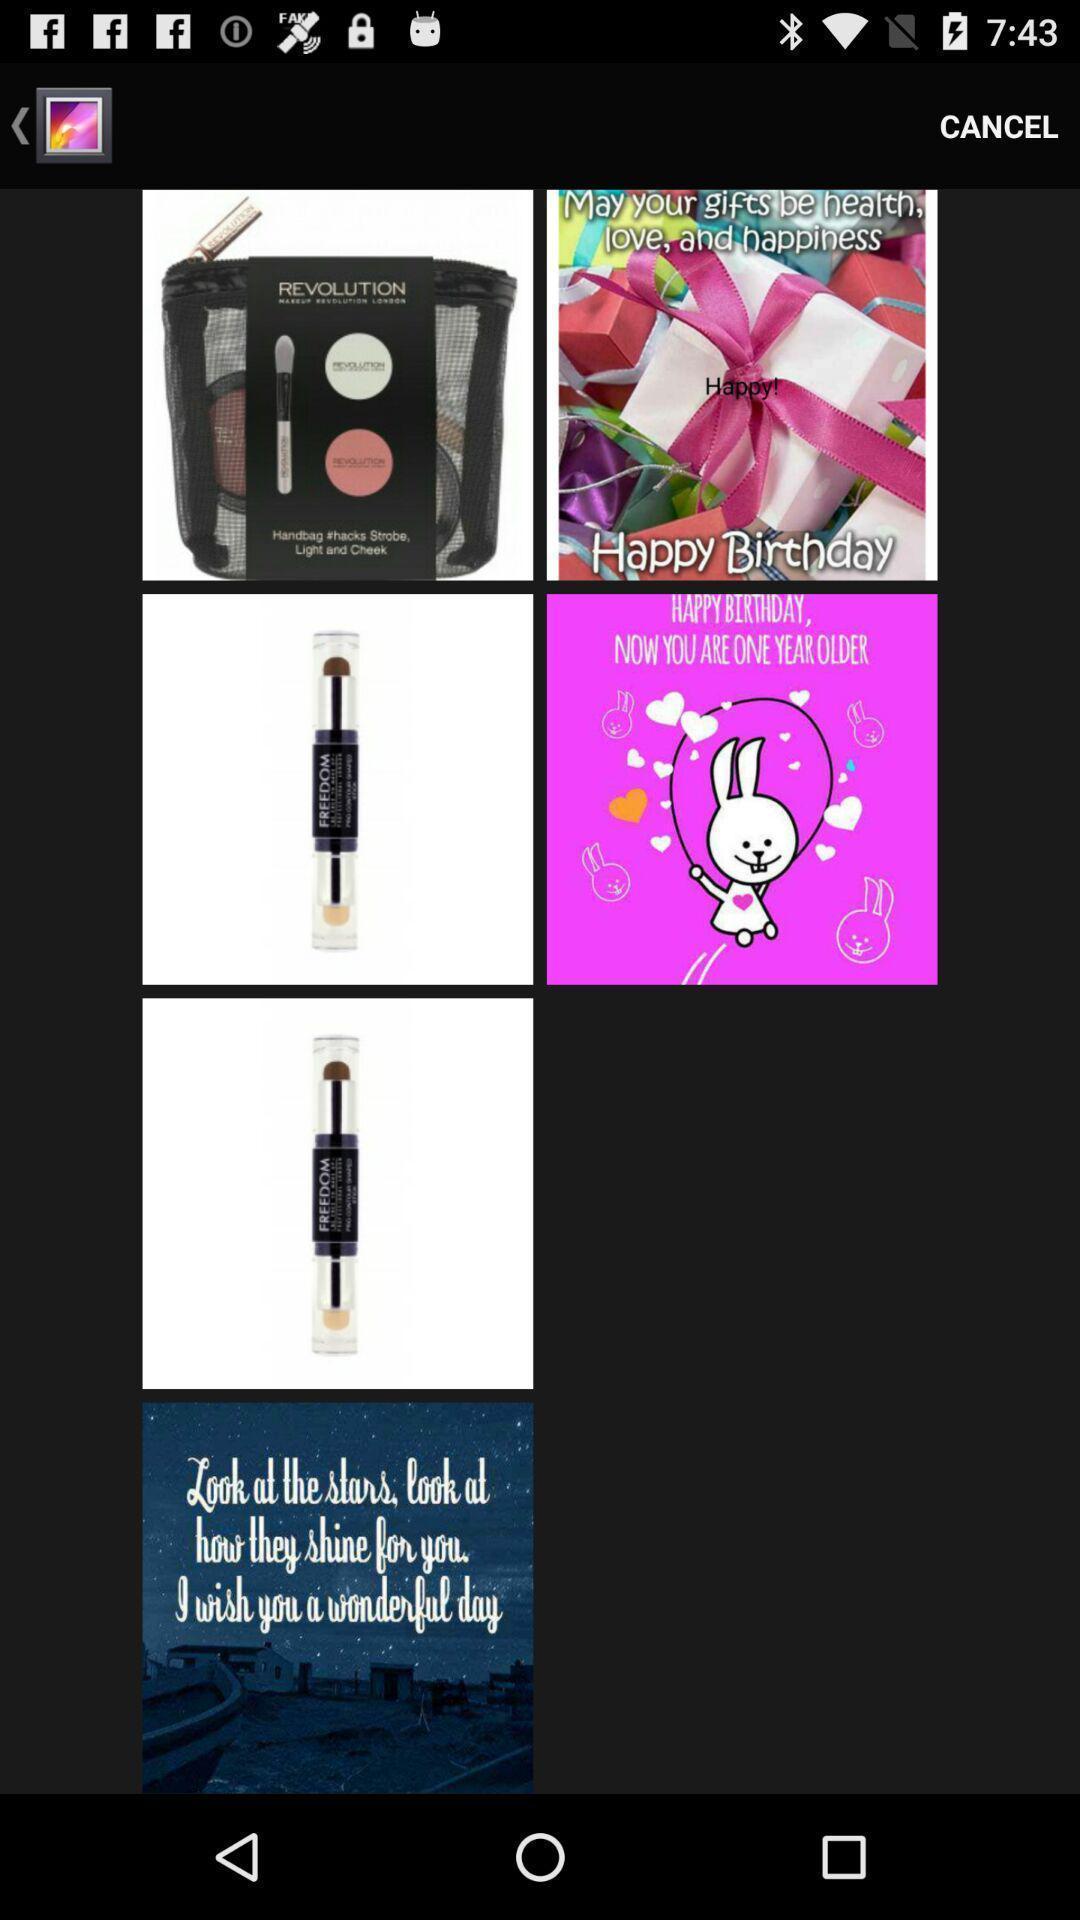What can you discern from this picture? Page showing different kinds of images with cancel option. 